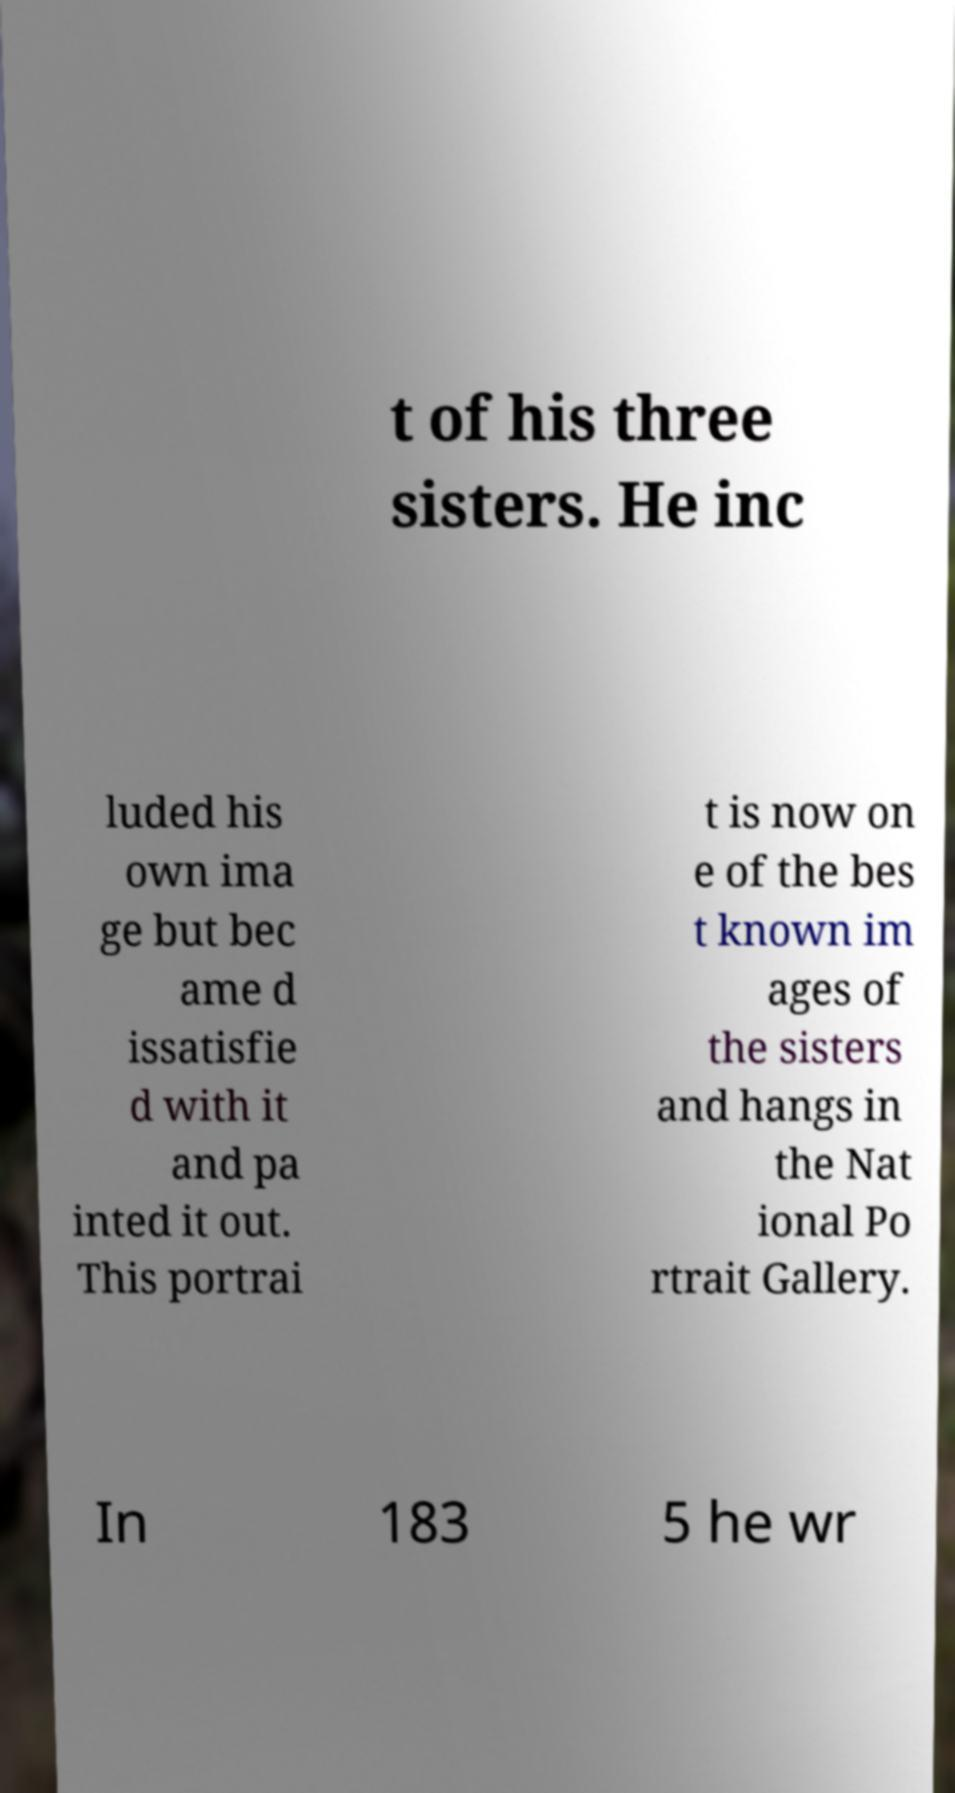For documentation purposes, I need the text within this image transcribed. Could you provide that? t of his three sisters. He inc luded his own ima ge but bec ame d issatisfie d with it and pa inted it out. This portrai t is now on e of the bes t known im ages of the sisters and hangs in the Nat ional Po rtrait Gallery. In 183 5 he wr 